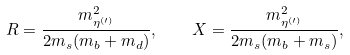Convert formula to latex. <formula><loc_0><loc_0><loc_500><loc_500>R = \frac { m _ { \eta ^ { ( \prime ) } } ^ { 2 } } { 2 m _ { s } ( m _ { b } + m _ { d } ) } , \quad X = \frac { m _ { \eta ^ { ( \prime ) } } ^ { 2 } } { 2 m _ { s } ( m _ { b } + m _ { s } ) } ,</formula> 